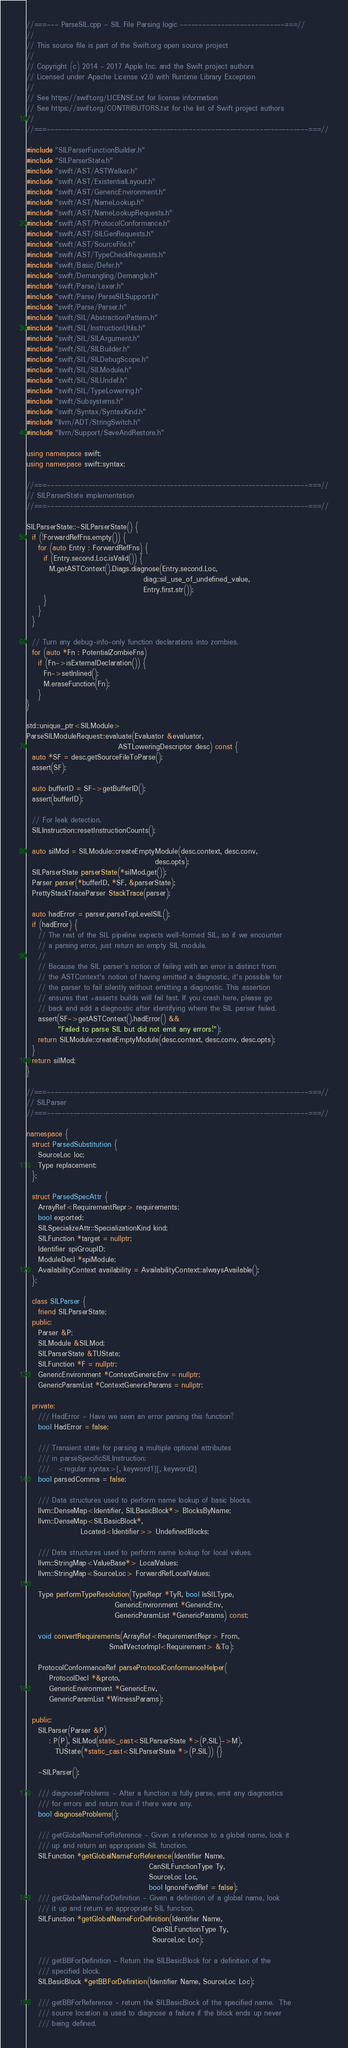<code> <loc_0><loc_0><loc_500><loc_500><_C++_>//===--- ParseSIL.cpp - SIL File Parsing logic ----------------------------===//
//
// This source file is part of the Swift.org open source project
//
// Copyright (c) 2014 - 2017 Apple Inc. and the Swift project authors
// Licensed under Apache License v2.0 with Runtime Library Exception
//
// See https://swift.org/LICENSE.txt for license information
// See https://swift.org/CONTRIBUTORS.txt for the list of Swift project authors
//
//===----------------------------------------------------------------------===//

#include "SILParserFunctionBuilder.h"
#include "SILParserState.h"
#include "swift/AST/ASTWalker.h"
#include "swift/AST/ExistentialLayout.h"
#include "swift/AST/GenericEnvironment.h"
#include "swift/AST/NameLookup.h"
#include "swift/AST/NameLookupRequests.h"
#include "swift/AST/ProtocolConformance.h"
#include "swift/AST/SILGenRequests.h"
#include "swift/AST/SourceFile.h"
#include "swift/AST/TypeCheckRequests.h"
#include "swift/Basic/Defer.h"
#include "swift/Demangling/Demangle.h"
#include "swift/Parse/Lexer.h"
#include "swift/Parse/ParseSILSupport.h"
#include "swift/Parse/Parser.h"
#include "swift/SIL/AbstractionPattern.h"
#include "swift/SIL/InstructionUtils.h"
#include "swift/SIL/SILArgument.h"
#include "swift/SIL/SILBuilder.h"
#include "swift/SIL/SILDebugScope.h"
#include "swift/SIL/SILModule.h"
#include "swift/SIL/SILUndef.h"
#include "swift/SIL/TypeLowering.h"
#include "swift/Subsystems.h"
#include "swift/Syntax/SyntaxKind.h"
#include "llvm/ADT/StringSwitch.h"
#include "llvm/Support/SaveAndRestore.h"

using namespace swift;
using namespace swift::syntax;

//===----------------------------------------------------------------------===//
// SILParserState implementation
//===----------------------------------------------------------------------===//

SILParserState::~SILParserState() {
  if (!ForwardRefFns.empty()) {
    for (auto Entry : ForwardRefFns) {
      if (Entry.second.Loc.isValid()) {
        M.getASTContext().Diags.diagnose(Entry.second.Loc,
                                         diag::sil_use_of_undefined_value,
                                         Entry.first.str());
      }
    }
  }

  // Turn any debug-info-only function declarations into zombies.
  for (auto *Fn : PotentialZombieFns)
    if (Fn->isExternalDeclaration()) {
      Fn->setInlined();
      M.eraseFunction(Fn);
    }
}

std::unique_ptr<SILModule>
ParseSILModuleRequest::evaluate(Evaluator &evaluator,
                                ASTLoweringDescriptor desc) const {
  auto *SF = desc.getSourceFileToParse();
  assert(SF);

  auto bufferID = SF->getBufferID();
  assert(bufferID);

  // For leak detection.
  SILInstruction::resetInstructionCounts();

  auto silMod = SILModule::createEmptyModule(desc.context, desc.conv,
                                             desc.opts);
  SILParserState parserState(*silMod.get());
  Parser parser(*bufferID, *SF, &parserState);
  PrettyStackTraceParser StackTrace(parser);

  auto hadError = parser.parseTopLevelSIL();
  if (hadError) {
    // The rest of the SIL pipeline expects well-formed SIL, so if we encounter
    // a parsing error, just return an empty SIL module.
    //
    // Because the SIL parser's notion of failing with an error is distinct from
    // the ASTContext's notion of having emitted a diagnostic, it's possible for
    // the parser to fail silently without emitting a diagnostic. This assertion
    // ensures that +asserts builds will fail fast. If you crash here, please go
    // back and add a diagnostic after identifying where the SIL parser failed.
    assert(SF->getASTContext().hadError() &&
           "Failed to parse SIL but did not emit any errors!");
    return SILModule::createEmptyModule(desc.context, desc.conv, desc.opts);
  }
  return silMod;
}

//===----------------------------------------------------------------------===//
// SILParser
//===----------------------------------------------------------------------===//

namespace {
  struct ParsedSubstitution {
    SourceLoc loc;
    Type replacement;
  };

  struct ParsedSpecAttr {
    ArrayRef<RequirementRepr> requirements;
    bool exported;
    SILSpecializeAttr::SpecializationKind kind;
    SILFunction *target = nullptr;
    Identifier spiGroupID;
    ModuleDecl *spiModule;
    AvailabilityContext availability = AvailabilityContext::alwaysAvailable();
  };

  class SILParser {
    friend SILParserState;
  public:
    Parser &P;
    SILModule &SILMod;
    SILParserState &TUState;
    SILFunction *F = nullptr;
    GenericEnvironment *ContextGenericEnv = nullptr;
    GenericParamList *ContextGenericParams = nullptr;

  private:
    /// HadError - Have we seen an error parsing this function?
    bool HadError = false;

    /// Transient state for parsing a multiple optional attributes
    /// in parseSpecificSILInstruction:
    ///   <regular syntax>[, keyword1][, keyword2]
    bool parsedComma = false;

    /// Data structures used to perform name lookup of basic blocks.
    llvm::DenseMap<Identifier, SILBasicBlock*> BlocksByName;
    llvm::DenseMap<SILBasicBlock*,
                   Located<Identifier>> UndefinedBlocks;

    /// Data structures used to perform name lookup for local values.
    llvm::StringMap<ValueBase*> LocalValues;
    llvm::StringMap<SourceLoc> ForwardRefLocalValues;

    Type performTypeResolution(TypeRepr *TyR, bool IsSILType,
                               GenericEnvironment *GenericEnv,
                               GenericParamList *GenericParams) const;

    void convertRequirements(ArrayRef<RequirementRepr> From,
                             SmallVectorImpl<Requirement> &To);

    ProtocolConformanceRef parseProtocolConformanceHelper(
        ProtocolDecl *&proto,
        GenericEnvironment *GenericEnv,
        GenericParamList *WitnessParams);

  public:
    SILParser(Parser &P)
        : P(P), SILMod(static_cast<SILParserState *>(P.SIL)->M),
          TUState(*static_cast<SILParserState *>(P.SIL)) {}

    ~SILParser();

    /// diagnoseProblems - After a function is fully parse, emit any diagnostics
    /// for errors and return true if there were any.
    bool diagnoseProblems();

    /// getGlobalNameForReference - Given a reference to a global name, look it
    /// up and return an appropriate SIL function.
    SILFunction *getGlobalNameForReference(Identifier Name,
                                           CanSILFunctionType Ty,
                                           SourceLoc Loc,
                                           bool IgnoreFwdRef = false);
    /// getGlobalNameForDefinition - Given a definition of a global name, look
    /// it up and return an appropriate SIL function.
    SILFunction *getGlobalNameForDefinition(Identifier Name,
                                            CanSILFunctionType Ty,
                                            SourceLoc Loc);

    /// getBBForDefinition - Return the SILBasicBlock for a definition of the
    /// specified block.
    SILBasicBlock *getBBForDefinition(Identifier Name, SourceLoc Loc);
    
    /// getBBForReference - return the SILBasicBlock of the specified name.  The
    /// source location is used to diagnose a failure if the block ends up never
    /// being defined.</code> 